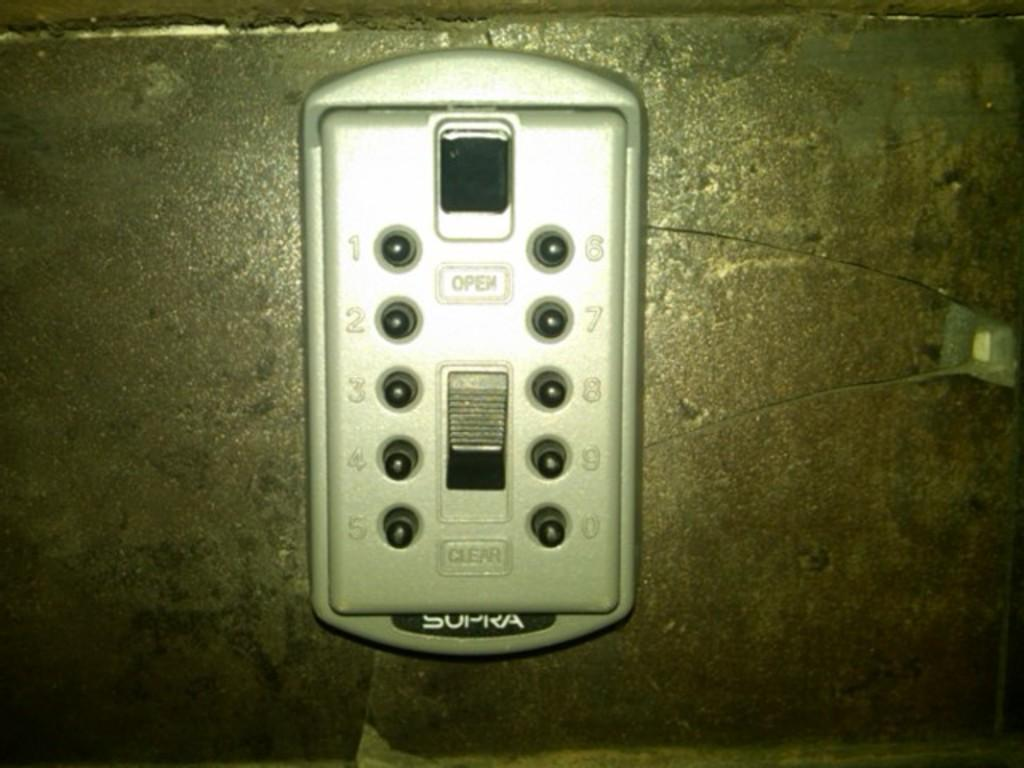<image>
Render a clear and concise summary of the photo. A closeup of a sopra control panel that has open and clear buttons on it. 